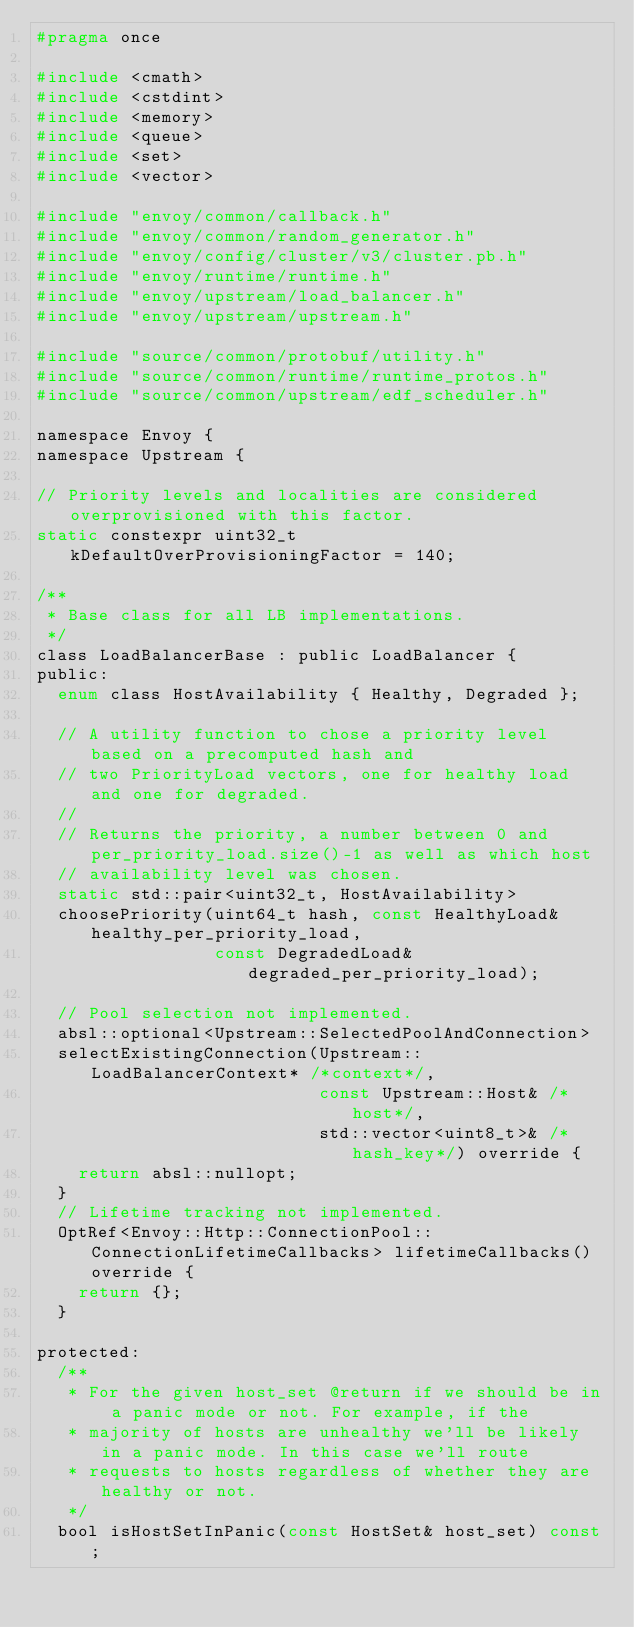Convert code to text. <code><loc_0><loc_0><loc_500><loc_500><_C_>#pragma once

#include <cmath>
#include <cstdint>
#include <memory>
#include <queue>
#include <set>
#include <vector>

#include "envoy/common/callback.h"
#include "envoy/common/random_generator.h"
#include "envoy/config/cluster/v3/cluster.pb.h"
#include "envoy/runtime/runtime.h"
#include "envoy/upstream/load_balancer.h"
#include "envoy/upstream/upstream.h"

#include "source/common/protobuf/utility.h"
#include "source/common/runtime/runtime_protos.h"
#include "source/common/upstream/edf_scheduler.h"

namespace Envoy {
namespace Upstream {

// Priority levels and localities are considered overprovisioned with this factor.
static constexpr uint32_t kDefaultOverProvisioningFactor = 140;

/**
 * Base class for all LB implementations.
 */
class LoadBalancerBase : public LoadBalancer {
public:
  enum class HostAvailability { Healthy, Degraded };

  // A utility function to chose a priority level based on a precomputed hash and
  // two PriorityLoad vectors, one for healthy load and one for degraded.
  //
  // Returns the priority, a number between 0 and per_priority_load.size()-1 as well as which host
  // availability level was chosen.
  static std::pair<uint32_t, HostAvailability>
  choosePriority(uint64_t hash, const HealthyLoad& healthy_per_priority_load,
                 const DegradedLoad& degraded_per_priority_load);

  // Pool selection not implemented.
  absl::optional<Upstream::SelectedPoolAndConnection>
  selectExistingConnection(Upstream::LoadBalancerContext* /*context*/,
                           const Upstream::Host& /*host*/,
                           std::vector<uint8_t>& /*hash_key*/) override {
    return absl::nullopt;
  }
  // Lifetime tracking not implemented.
  OptRef<Envoy::Http::ConnectionPool::ConnectionLifetimeCallbacks> lifetimeCallbacks() override {
    return {};
  }

protected:
  /**
   * For the given host_set @return if we should be in a panic mode or not. For example, if the
   * majority of hosts are unhealthy we'll be likely in a panic mode. In this case we'll route
   * requests to hosts regardless of whether they are healthy or not.
   */
  bool isHostSetInPanic(const HostSet& host_set) const;
</code> 